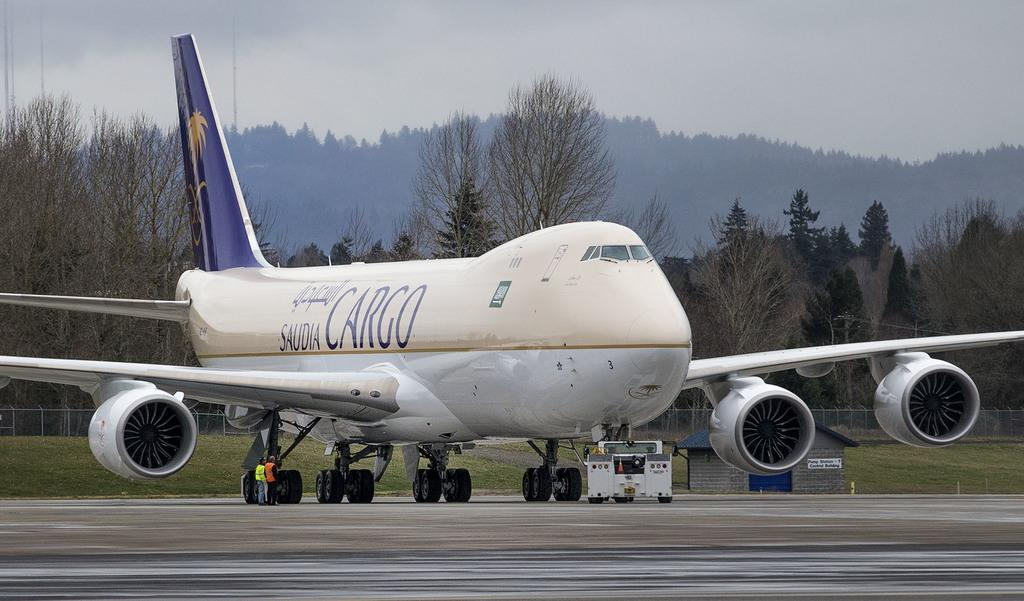<image>
Write a terse but informative summary of the picture. a plane with the words Saudia Cargo on the side 